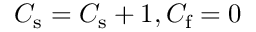Convert formula to latex. <formula><loc_0><loc_0><loc_500><loc_500>C _ { s } = C _ { s } + 1 , C _ { f } = 0</formula> 